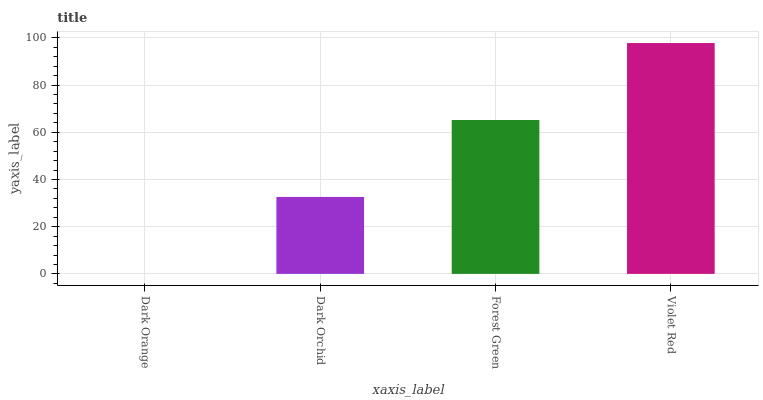Is Dark Orange the minimum?
Answer yes or no. Yes. Is Violet Red the maximum?
Answer yes or no. Yes. Is Dark Orchid the minimum?
Answer yes or no. No. Is Dark Orchid the maximum?
Answer yes or no. No. Is Dark Orchid greater than Dark Orange?
Answer yes or no. Yes. Is Dark Orange less than Dark Orchid?
Answer yes or no. Yes. Is Dark Orange greater than Dark Orchid?
Answer yes or no. No. Is Dark Orchid less than Dark Orange?
Answer yes or no. No. Is Forest Green the high median?
Answer yes or no. Yes. Is Dark Orchid the low median?
Answer yes or no. Yes. Is Dark Orchid the high median?
Answer yes or no. No. Is Violet Red the low median?
Answer yes or no. No. 